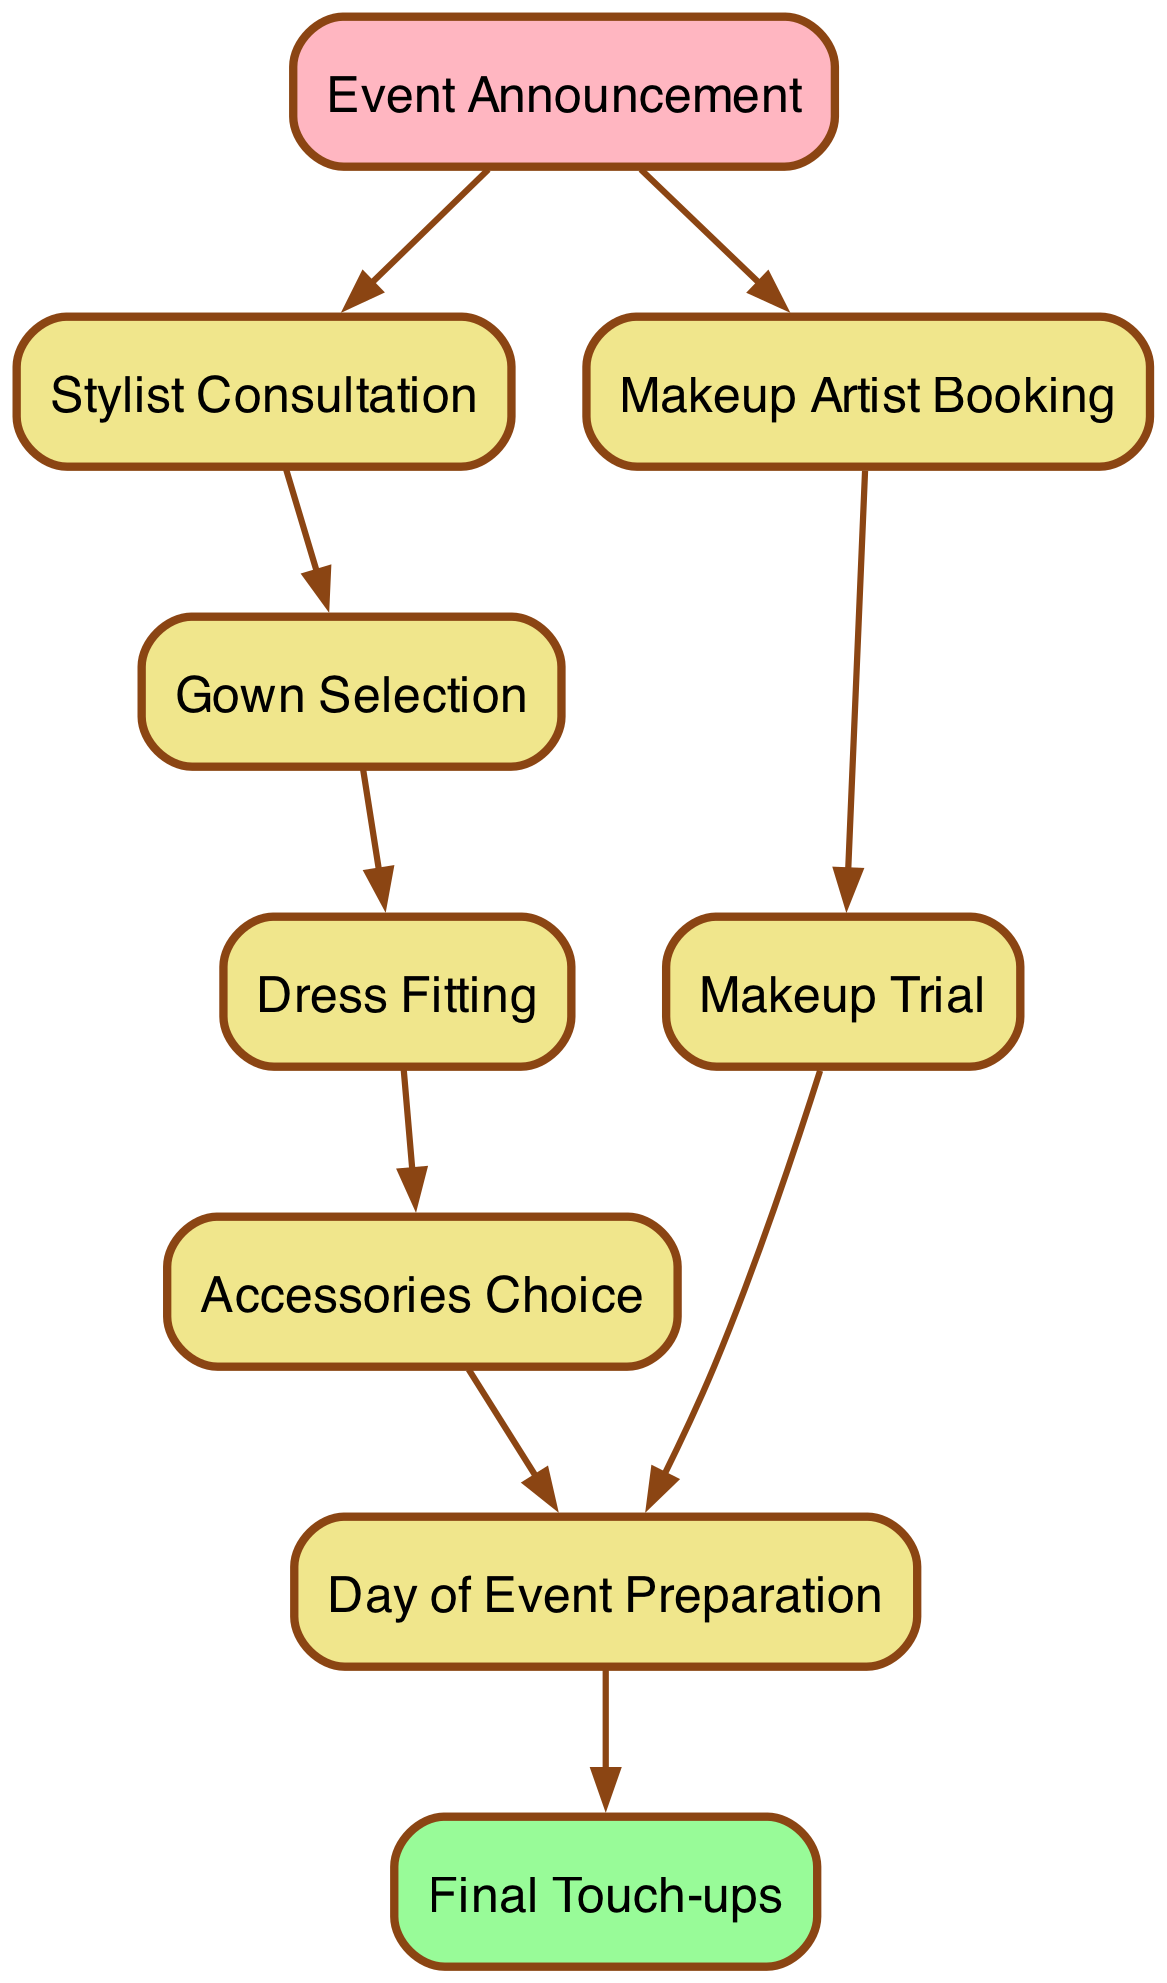What is the first step in the process? The first element in the diagram is "Event Announcement," indicated by its position at the top. It does not have any preceding nodes, which confirms its role as the starting point.
Answer: Event Announcement How many main steps are there in total? By counting the number of unique elements (nodes) connected in the diagram, it can be identified that there are 9 distinct steps or nodes listed.
Answer: 9 What connects "Makeup Artist Booking" to "Day of Event Preparation"? The connection between "Makeup Artist Booking" and "Day of Event Preparation" is direct, as indicated by the edge drawn from node 3 (Makeup Artist Booking) to node 8 (Day of Event Preparation).
Answer: Makeup Trial Which step directly follows "Dress Fitting"? "Accessories Choice" follows directly after "Dress Fitting," shown by the connection from node 5 to node 6 in the diagram.
Answer: Accessories Choice How are "Makeup Trial" and "Accessories Choice" related? Both "Makeup Trial" and "Accessories Choice" directly connect to the same subsequent step, "Day of Event Preparation," suggesting that both steps are essential before this final preparation stage.
Answer: Day of Event Preparation Which node is the last step before the final touch-ups? The last node before "Final Touch-ups" is "Day of Event Preparation," clearly identified by the directed edge that leads to the final touch-up stage.
Answer: Day of Event Preparation What color represents the event announcement in the diagram? The "Event Announcement" node is highlighted in a different color, specifically pink, to denote its importance as the starting point of the process.
Answer: Pink How many connections does the "Gown Selection" step have? "Gown Selection," represented by node 4, has only one outgoing connection, which leads to the "Dress Fitting," indicating it proceeds to only one sequential step.
Answer: 1 What is the final step of the makeup and wardrobe preparation process? The process ends with "Final Touch-ups," which is the last node at the bottom of the diagram, confirming it as the concluding action.
Answer: Final Touch-ups 